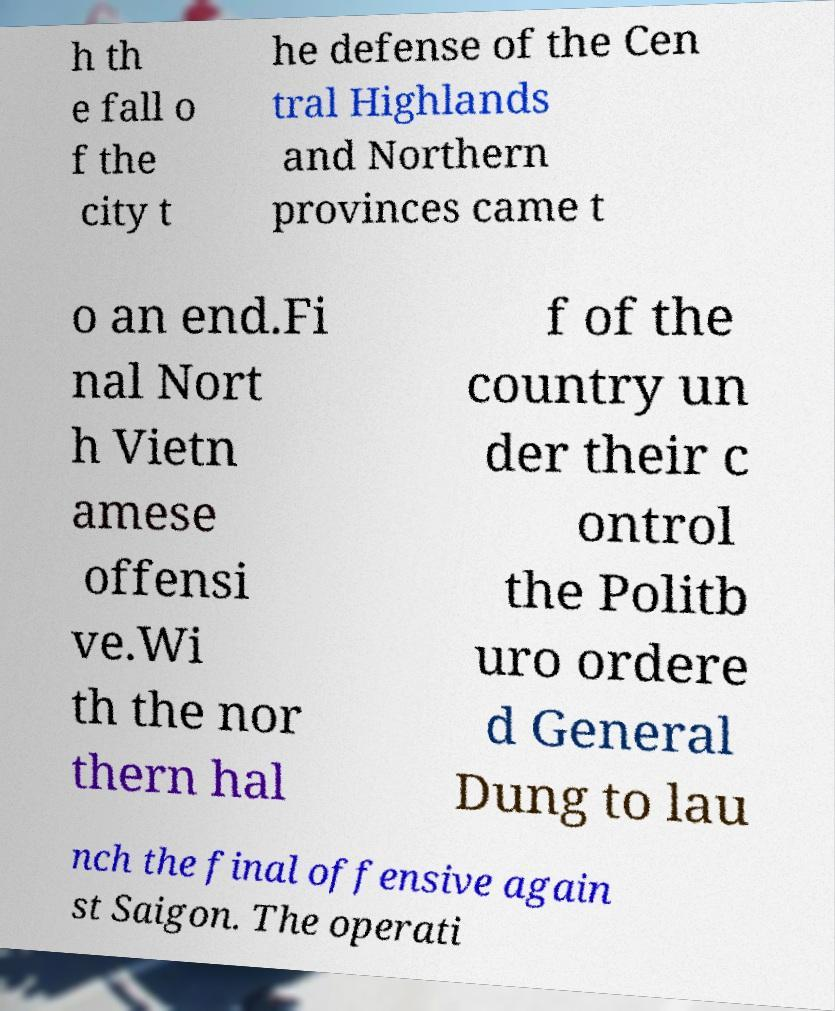For documentation purposes, I need the text within this image transcribed. Could you provide that? h th e fall o f the city t he defense of the Cen tral Highlands and Northern provinces came t o an end.Fi nal Nort h Vietn amese offensi ve.Wi th the nor thern hal f of the country un der their c ontrol the Politb uro ordere d General Dung to lau nch the final offensive again st Saigon. The operati 